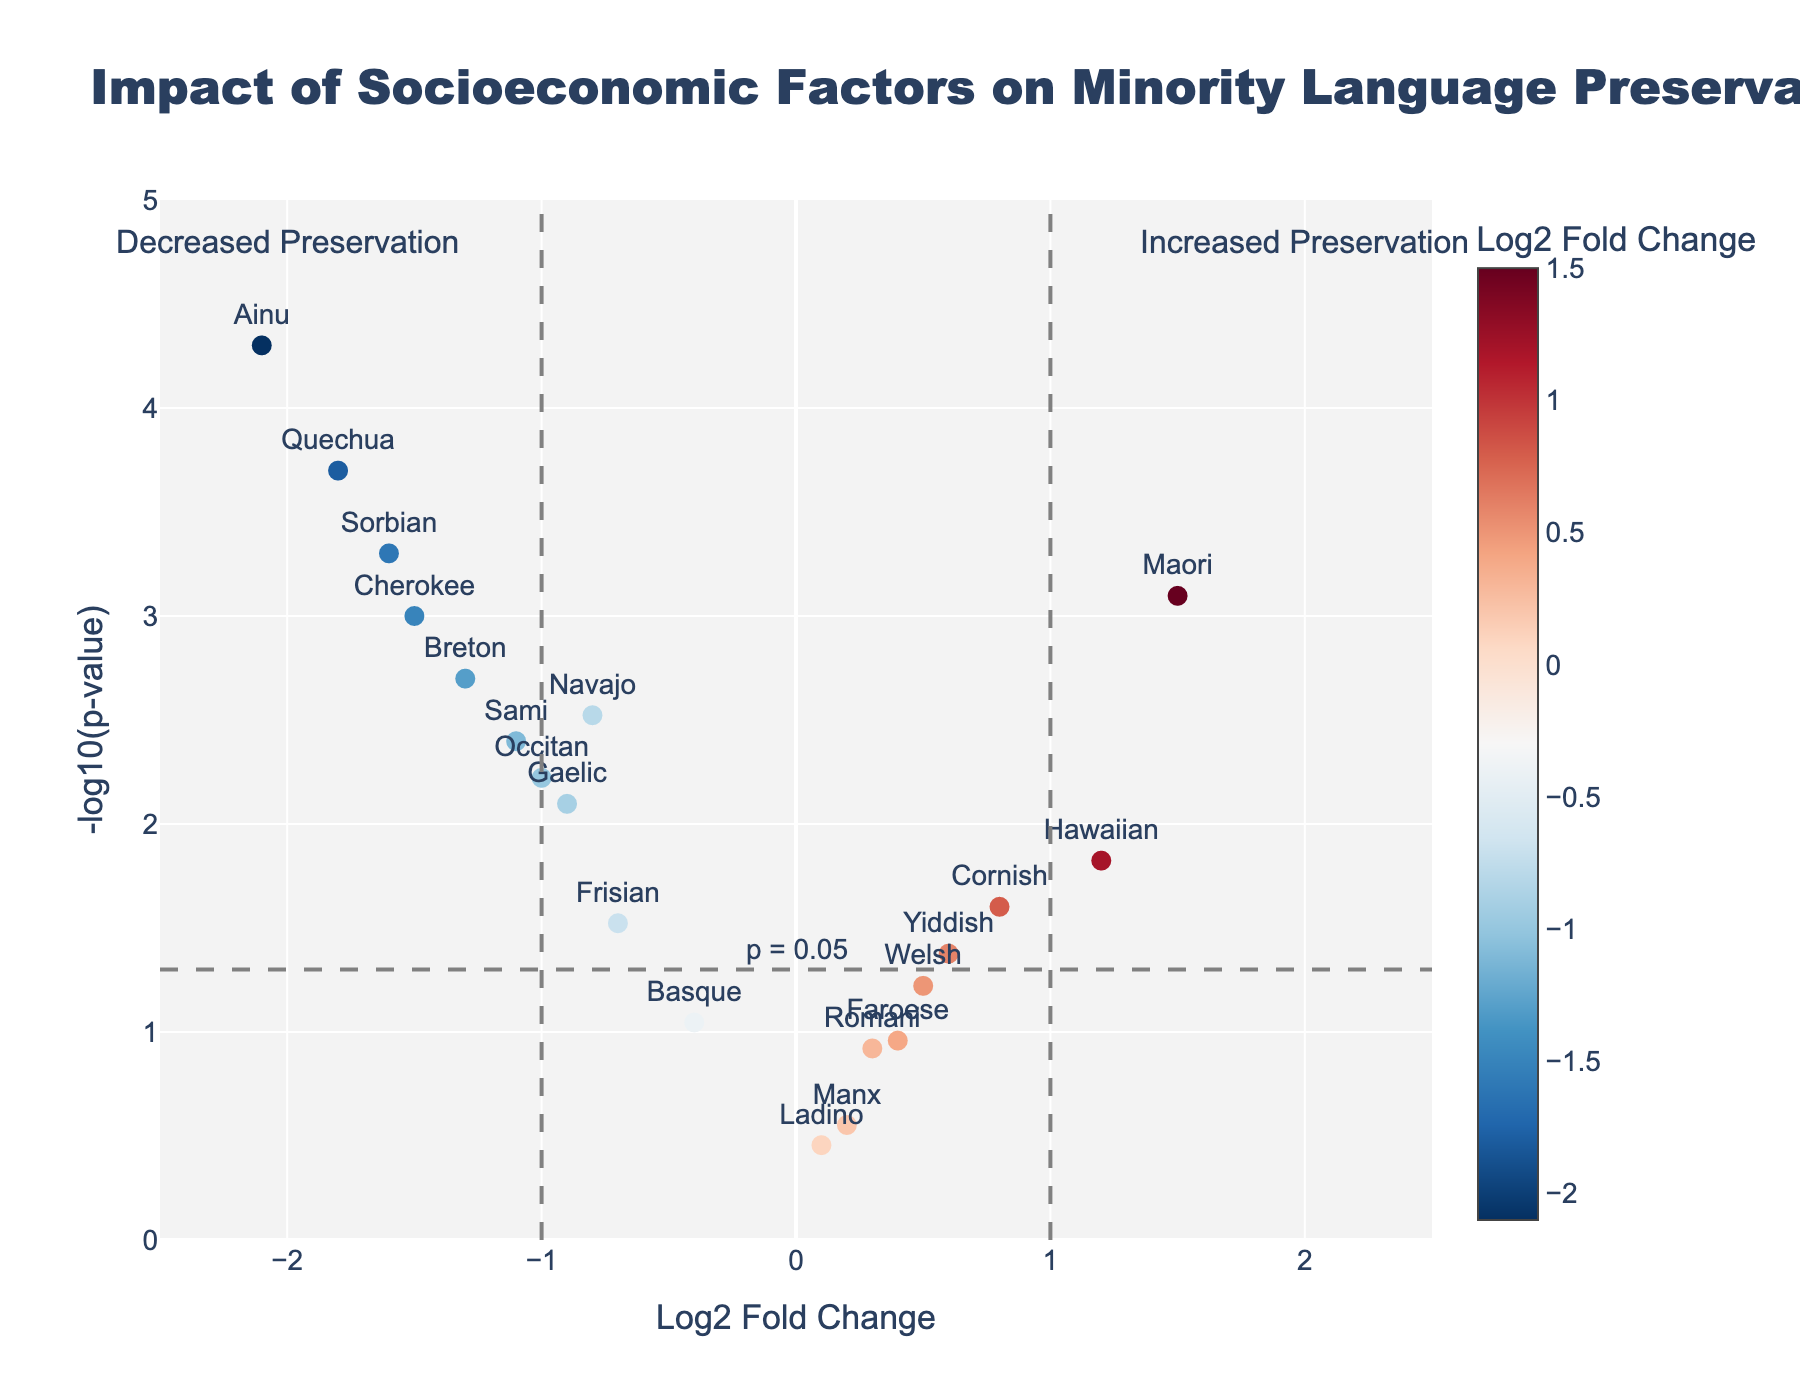How many languages showed increased preservation? Languages with positive Log2 Fold Change (LogFC) indicate increased preservation. From the plot, we can count the languages above zero on the x-axis which are Welsh, Maori, Hawaiian, Yiddish, Cornish, Romani, and Faroese.
Answer: 7 Which language had the most significant decrease in preservation? The most significant decrease in preservation would be identified by a high negative Log2 Fold Change (LogFC) and a low p-value. Ainu has the largest negative LogFC and a very small p-value.
Answer: Ainu What is the significance level (p-value) threshold used in the plot? The threshold line at -log10(p-value) = 1.301 represents p = 0.05, as -log10(0.05) = 1.301.
Answer: 0.05 How many languages are considered statistically significant in the plot? Statistically significant points lie above the threshold line of -log10(p-value) > 1.301. Count all points above this threshold. Languages like Navajo, Hawaiian, Cherokee, etc.
Answer: 12 Which languages have Log2 Fold Change values greater than 1? LogFC greater than 1 represents significantly increased preservation. From the plot, these languages are Maori and Hawaiian as they lie to the right of x=1.
Answer: Maori and Hawaiian Is there a language with a significant preservation increase above the threshold line? Significant preservation increase is marked by a LogFC greater than the threshold and above the p-value cut line. Maori and Hawaiian fit these criteria perfectly.
Answer: Maori and Hawaiian Which language with a statistically significant preservation decrease has the smallest p-value? Among the languages with LogFC < 0 above the threshold line, the one with the lowest p-value will be identified by the highest y-value. Ainu is the one with the smallest p-value as it has the highest y-value.
Answer: Ainu What can be inferred about the preservation of the Cornish language? The Cornish language has a positive LogFC of 0.8, indicating increased preservation. Its p-value is less than the threshold, so it's also statistically significant.
Answer: Increased preservation, statistically significant 